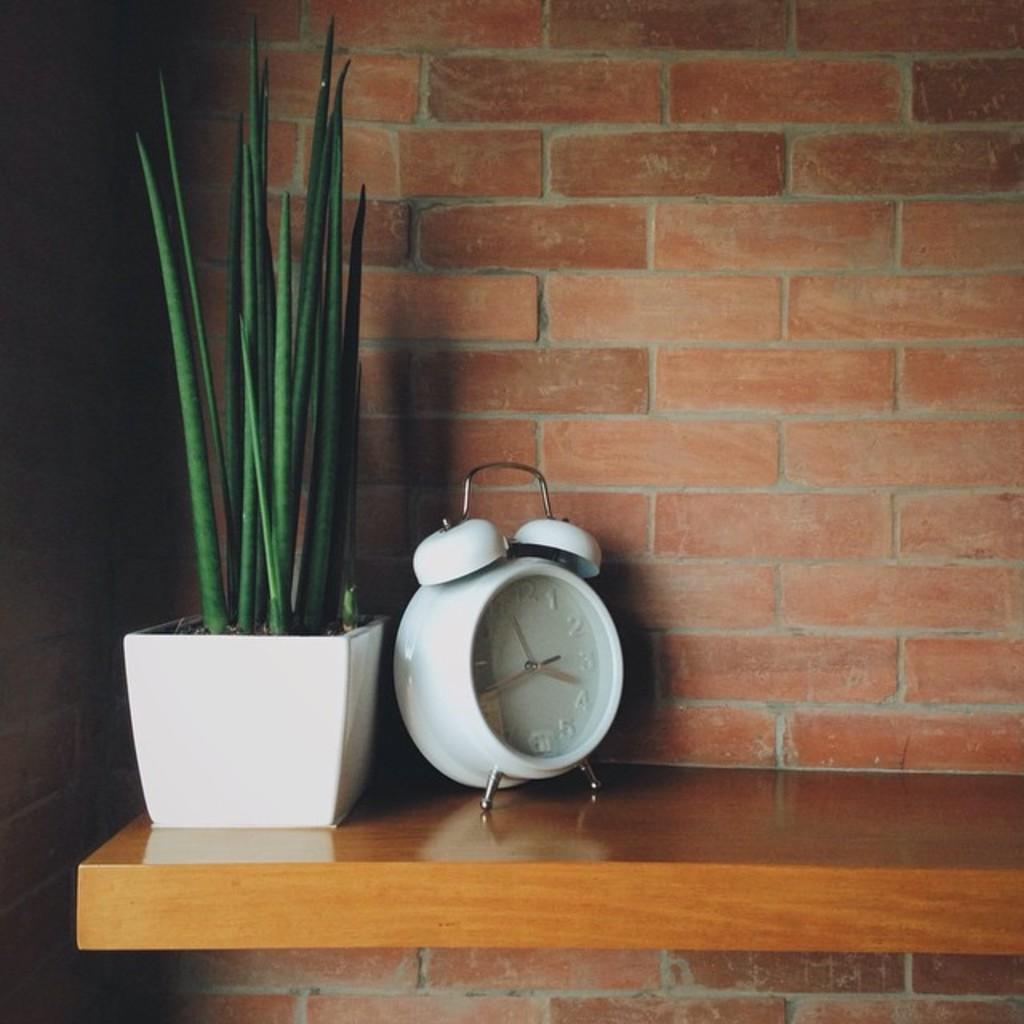What is on the wooden desk in the image? There is a small plant pot on the wooden desk. What is located near the plant pot? There is a clock beside the plant. What can be seen in the background of the image? There is a wall in the background of the image. What type of pleasure can be seen in the image? There is no indication of pleasure in the image; it features a plant pot, a clock, and a wall. How many nails are visible in the image? There are no nails visible in the image. 